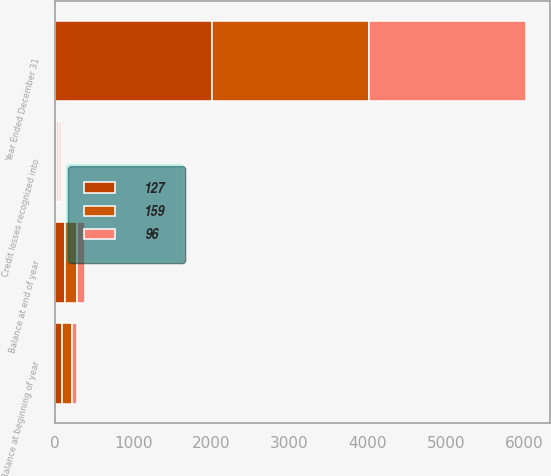Convert chart. <chart><loc_0><loc_0><loc_500><loc_500><stacked_bar_chart><ecel><fcel>Year Ended December 31<fcel>Balance at beginning of year<fcel>Credit losses recognized into<fcel>Balance at end of year<nl><fcel>159<fcel>2012<fcel>127<fcel>26<fcel>159<nl><fcel>127<fcel>2011<fcel>96<fcel>25<fcel>127<nl><fcel>96<fcel>2010<fcel>60<fcel>29<fcel>96<nl></chart> 